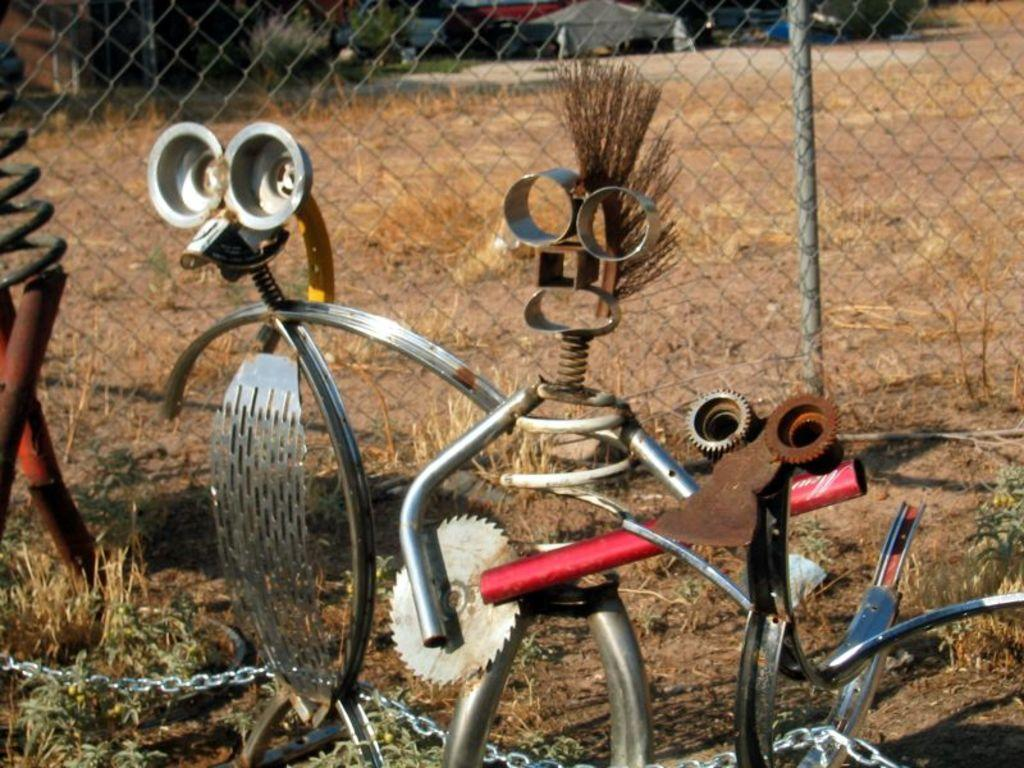What is the main object on the ground in the image? The facts do not specify the type of object on the ground. What type of barrier can be seen in the image? There is a fence in the image. Can you describe any other elements in the image? The facts only mention that there are other unspecified things in the image. Is the coat hanging on the fence in the image? There is no mention of a coat in the image, so we cannot answer this question. Can you tell me how many parents are visible in the image? There is no mention of parents in the image, so we cannot answer this question. 